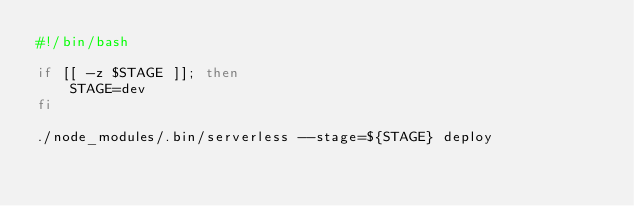<code> <loc_0><loc_0><loc_500><loc_500><_Bash_>#!/bin/bash

if [[ -z $STAGE ]]; then
    STAGE=dev
fi

./node_modules/.bin/serverless --stage=${STAGE} deploy
</code> 